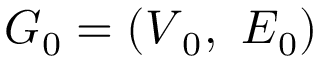Convert formula to latex. <formula><loc_0><loc_0><loc_500><loc_500>G _ { 0 } = ( V _ { 0 } , \ E _ { 0 } )</formula> 